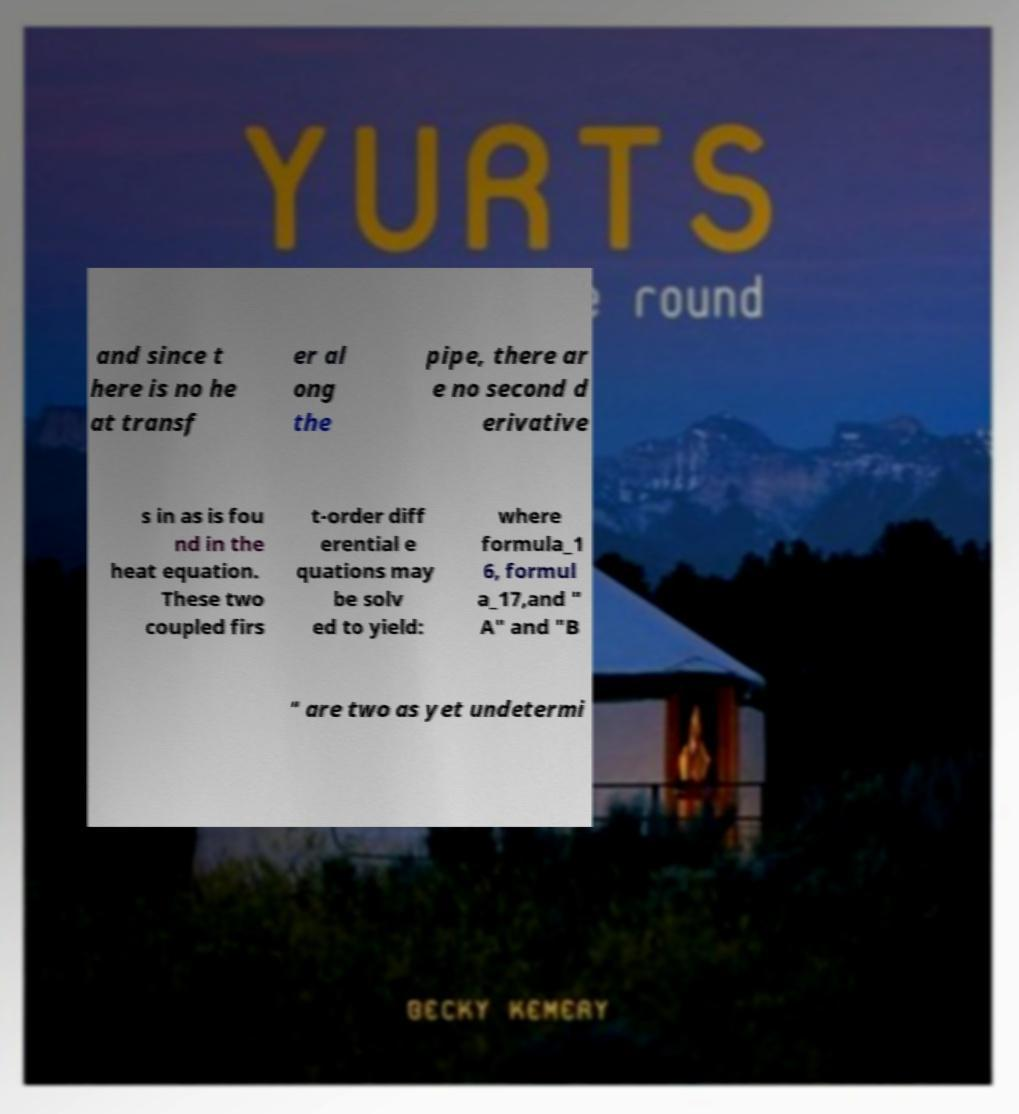There's text embedded in this image that I need extracted. Can you transcribe it verbatim? and since t here is no he at transf er al ong the pipe, there ar e no second d erivative s in as is fou nd in the heat equation. These two coupled firs t-order diff erential e quations may be solv ed to yield: where formula_1 6, formul a_17,and " A" and "B " are two as yet undetermi 